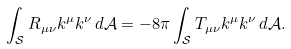Convert formula to latex. <formula><loc_0><loc_0><loc_500><loc_500>\int _ { \mathcal { S } } R _ { \mu \nu } k ^ { \mu } k ^ { \nu } \, d \mathcal { A } = - 8 \pi \int _ { \mathcal { S } } T _ { \mu \nu } k ^ { \mu } k ^ { \nu } \, d \mathcal { A } .</formula> 